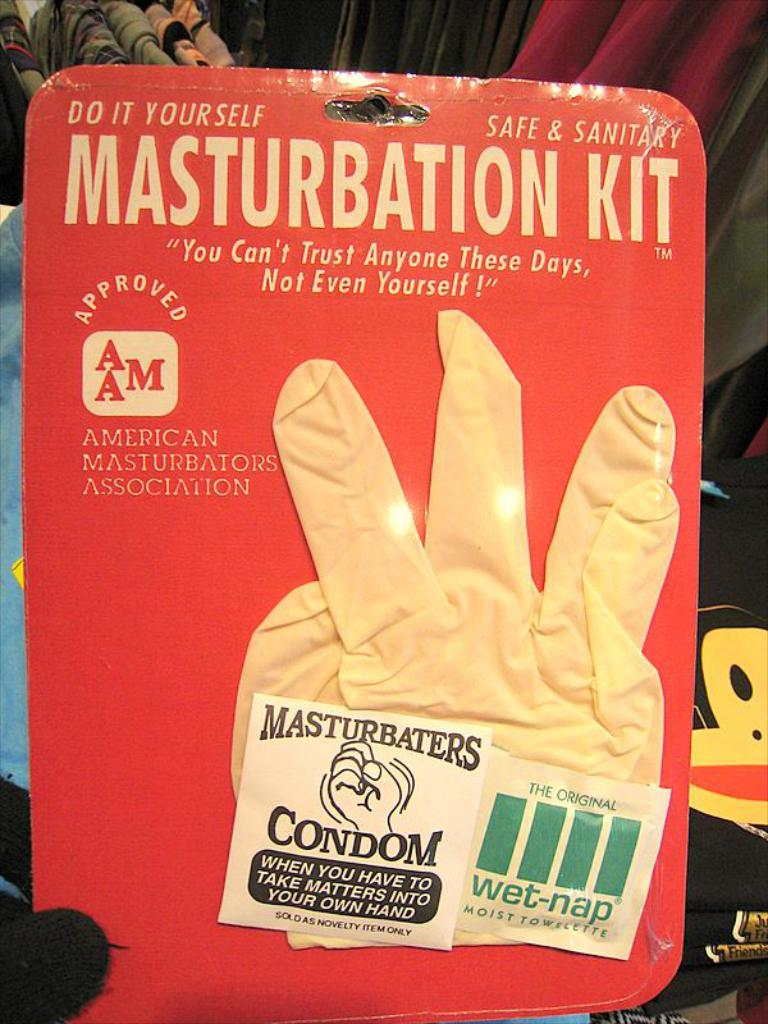<image>
Render a clear and concise summary of the photo. A packaged Masturbation Kit consisting of a rubber glove, a condom, and a wet-nap. 